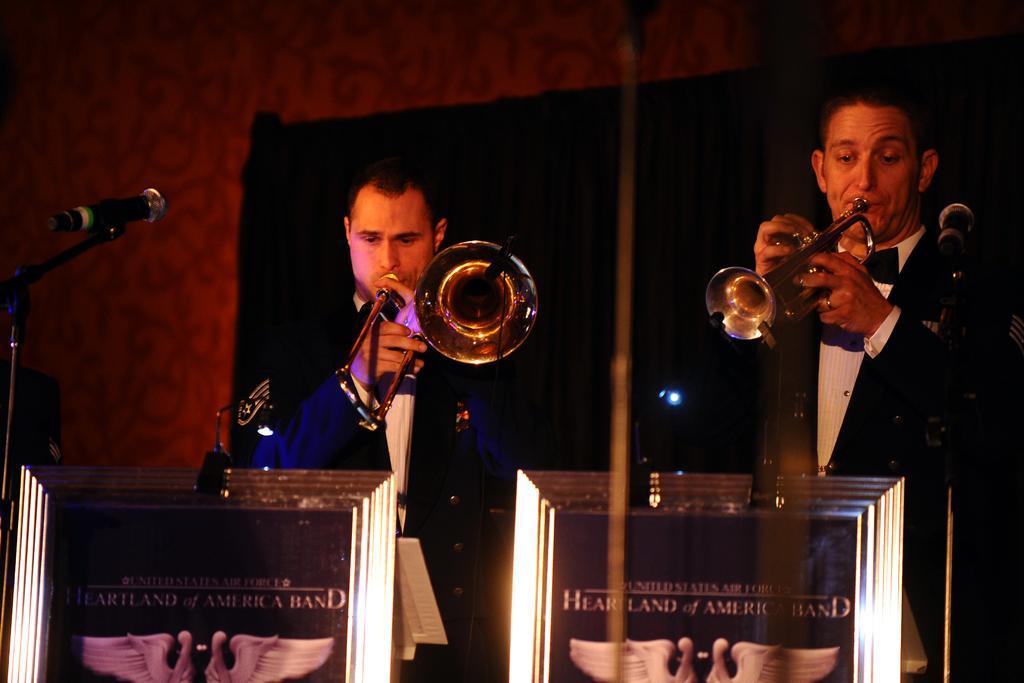How would you summarize this image in a sentence or two? In the image there are black suit playing trumpets in front of dias and behind them there is hall, there is a mic on the left side, 